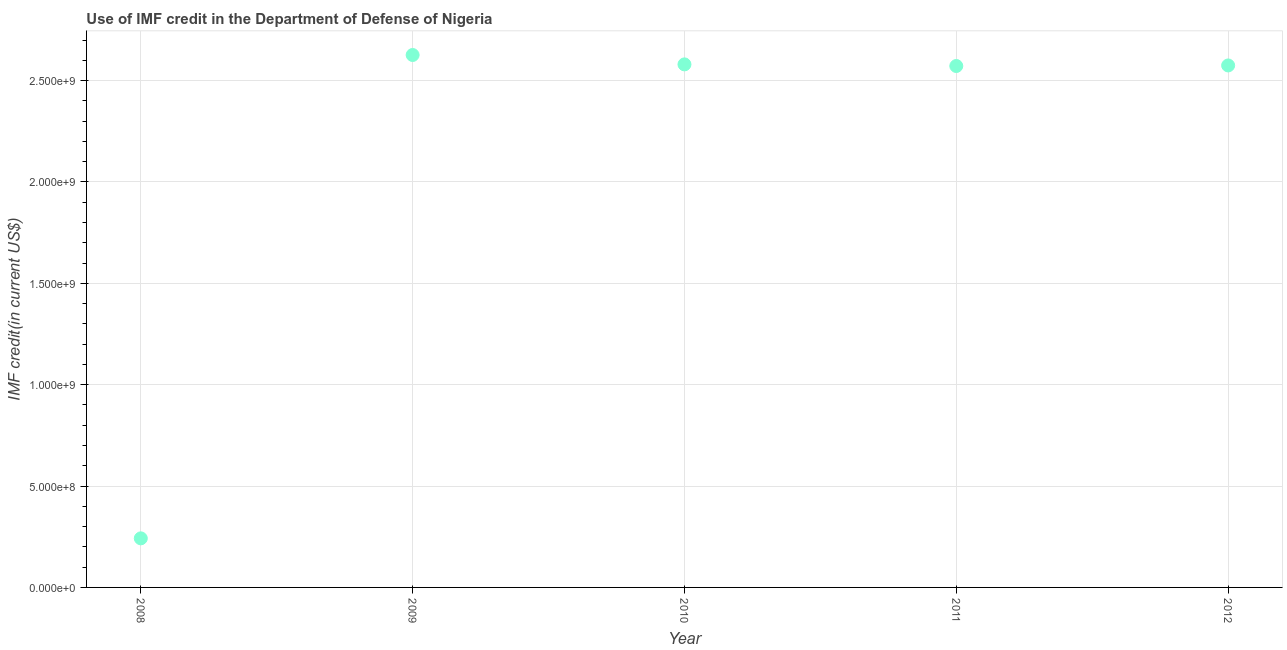What is the use of imf credit in dod in 2011?
Your answer should be very brief. 2.57e+09. Across all years, what is the maximum use of imf credit in dod?
Your answer should be compact. 2.63e+09. Across all years, what is the minimum use of imf credit in dod?
Offer a terse response. 2.42e+08. In which year was the use of imf credit in dod maximum?
Your response must be concise. 2009. In which year was the use of imf credit in dod minimum?
Ensure brevity in your answer.  2008. What is the sum of the use of imf credit in dod?
Ensure brevity in your answer.  1.06e+1. What is the difference between the use of imf credit in dod in 2008 and 2012?
Ensure brevity in your answer.  -2.33e+09. What is the average use of imf credit in dod per year?
Provide a succinct answer. 2.12e+09. What is the median use of imf credit in dod?
Keep it short and to the point. 2.57e+09. In how many years, is the use of imf credit in dod greater than 2100000000 US$?
Your answer should be very brief. 4. Do a majority of the years between 2009 and 2011 (inclusive) have use of imf credit in dod greater than 1500000000 US$?
Offer a terse response. Yes. What is the ratio of the use of imf credit in dod in 2008 to that in 2010?
Keep it short and to the point. 0.09. Is the difference between the use of imf credit in dod in 2008 and 2010 greater than the difference between any two years?
Provide a short and direct response. No. What is the difference between the highest and the second highest use of imf credit in dod?
Your answer should be very brief. 4.63e+07. What is the difference between the highest and the lowest use of imf credit in dod?
Offer a very short reply. 2.38e+09. What is the title of the graph?
Offer a terse response. Use of IMF credit in the Department of Defense of Nigeria. What is the label or title of the Y-axis?
Give a very brief answer. IMF credit(in current US$). What is the IMF credit(in current US$) in 2008?
Make the answer very short. 2.42e+08. What is the IMF credit(in current US$) in 2009?
Provide a short and direct response. 2.63e+09. What is the IMF credit(in current US$) in 2010?
Your answer should be very brief. 2.58e+09. What is the IMF credit(in current US$) in 2011?
Your answer should be compact. 2.57e+09. What is the IMF credit(in current US$) in 2012?
Make the answer very short. 2.57e+09. What is the difference between the IMF credit(in current US$) in 2008 and 2009?
Offer a very short reply. -2.38e+09. What is the difference between the IMF credit(in current US$) in 2008 and 2010?
Give a very brief answer. -2.34e+09. What is the difference between the IMF credit(in current US$) in 2008 and 2011?
Provide a succinct answer. -2.33e+09. What is the difference between the IMF credit(in current US$) in 2008 and 2012?
Offer a very short reply. -2.33e+09. What is the difference between the IMF credit(in current US$) in 2009 and 2010?
Keep it short and to the point. 4.63e+07. What is the difference between the IMF credit(in current US$) in 2009 and 2011?
Keep it short and to the point. 5.43e+07. What is the difference between the IMF credit(in current US$) in 2009 and 2012?
Your response must be concise. 5.16e+07. What is the difference between the IMF credit(in current US$) in 2010 and 2011?
Ensure brevity in your answer.  7.98e+06. What is the difference between the IMF credit(in current US$) in 2010 and 2012?
Your answer should be compact. 5.21e+06. What is the difference between the IMF credit(in current US$) in 2011 and 2012?
Offer a terse response. -2.76e+06. What is the ratio of the IMF credit(in current US$) in 2008 to that in 2009?
Keep it short and to the point. 0.09. What is the ratio of the IMF credit(in current US$) in 2008 to that in 2010?
Your response must be concise. 0.09. What is the ratio of the IMF credit(in current US$) in 2008 to that in 2011?
Offer a very short reply. 0.09. What is the ratio of the IMF credit(in current US$) in 2008 to that in 2012?
Keep it short and to the point. 0.09. What is the ratio of the IMF credit(in current US$) in 2009 to that in 2010?
Your answer should be compact. 1.02. What is the ratio of the IMF credit(in current US$) in 2009 to that in 2011?
Offer a terse response. 1.02. What is the ratio of the IMF credit(in current US$) in 2010 to that in 2012?
Keep it short and to the point. 1. What is the ratio of the IMF credit(in current US$) in 2011 to that in 2012?
Your answer should be very brief. 1. 